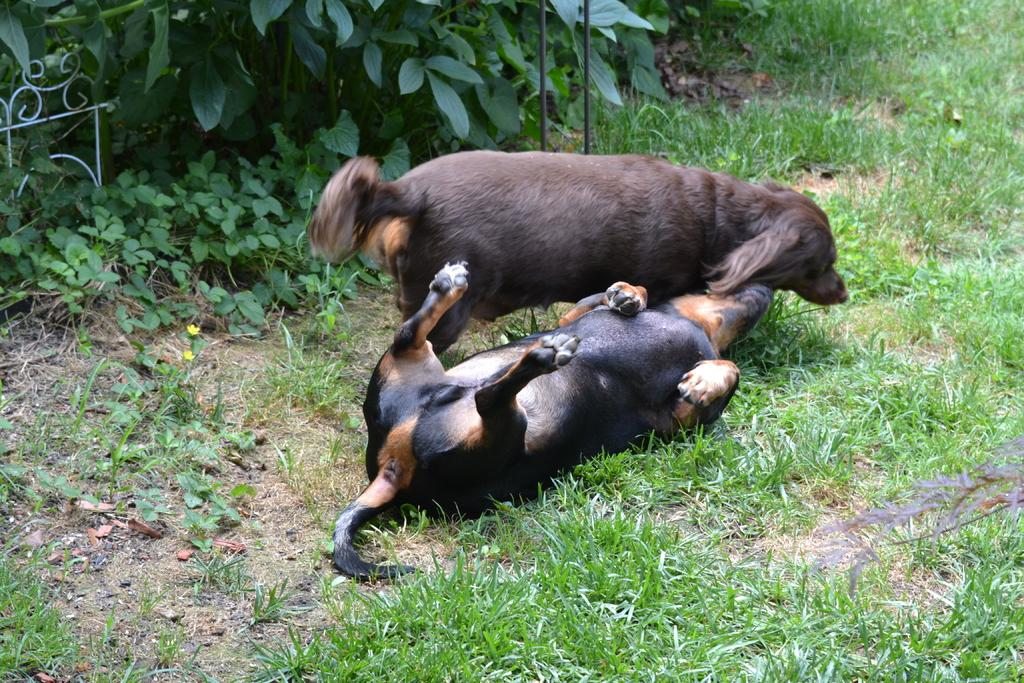How many dogs are present in the image? There are two dogs in the image. Where are the dogs located? The dogs are on the ground. What type of surface can be seen in the image? There is grass in the image. What objects can be seen in the image besides the dogs? There are rods and plants visible in the image. What type of oatmeal is being served to the dogs in the image? There is no oatmeal present in the image; it features two dogs on the ground with grass, rods, and plants visible in the background. 